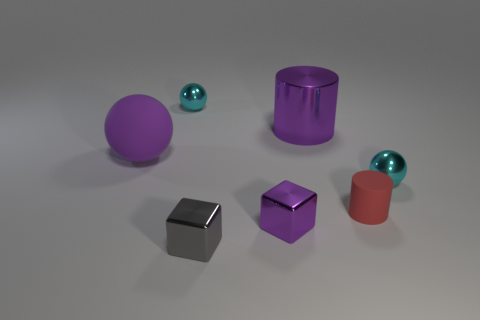How many tiny things are both in front of the big purple metal thing and behind the small gray metallic thing?
Your response must be concise. 3. What is the shape of the purple shiny object in front of the red cylinder?
Provide a short and direct response. Cube. What number of red things are made of the same material as the gray object?
Your answer should be compact. 0. Do the small red thing and the tiny purple shiny thing on the right side of the gray thing have the same shape?
Offer a terse response. No. There is a tiny cyan ball that is right of the large purple thing that is on the right side of the purple matte object; is there a gray metal thing that is to the right of it?
Your response must be concise. No. There is a cyan thing that is right of the tiny cylinder; what size is it?
Ensure brevity in your answer.  Small. There is a red cylinder that is the same size as the gray block; what material is it?
Give a very brief answer. Rubber. Does the tiny matte thing have the same shape as the small purple thing?
Your response must be concise. No. What number of objects are red rubber cylinders or cyan metallic things in front of the big matte sphere?
Provide a short and direct response. 2. What is the material of the small object that is the same color as the big rubber ball?
Provide a succinct answer. Metal. 